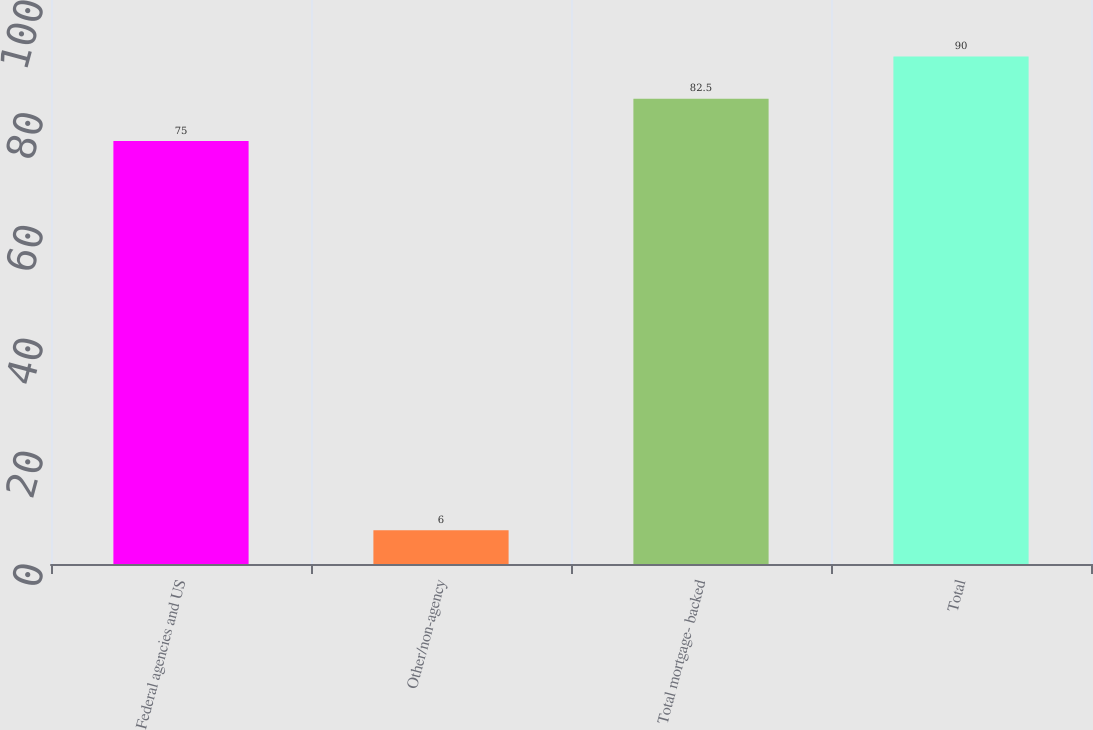Convert chart. <chart><loc_0><loc_0><loc_500><loc_500><bar_chart><fcel>Federal agencies and US<fcel>Other/non-agency<fcel>Total mortgage- backed<fcel>Total<nl><fcel>75<fcel>6<fcel>82.5<fcel>90<nl></chart> 